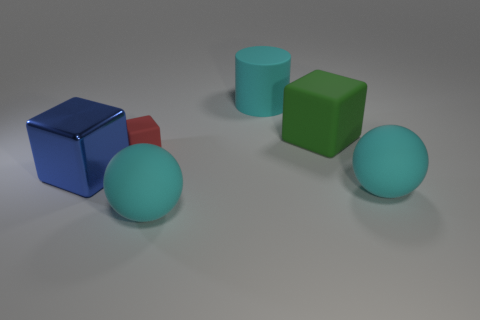Is there a matte cylinder of the same size as the green thing?
Keep it short and to the point. Yes. There is a block that is right of the cyan sphere left of the big block that is behind the big shiny cube; what is its material?
Offer a terse response. Rubber. What number of red rubber blocks are in front of the cyan matte object behind the red rubber block?
Ensure brevity in your answer.  1. Is the size of the green matte thing that is behind the blue metallic cube the same as the blue block?
Offer a terse response. Yes. How many large shiny things have the same shape as the red matte object?
Provide a succinct answer. 1. What is the shape of the big blue thing?
Your answer should be compact. Cube. Are there an equal number of tiny rubber cubes to the right of the large green matte object and large cyan objects?
Your response must be concise. No. Is there any other thing that is made of the same material as the big blue cube?
Provide a succinct answer. No. Does the cube that is right of the small rubber cube have the same material as the big cylinder?
Offer a terse response. Yes. Are there fewer cyan matte things that are in front of the green block than big cyan objects?
Offer a very short reply. Yes. 